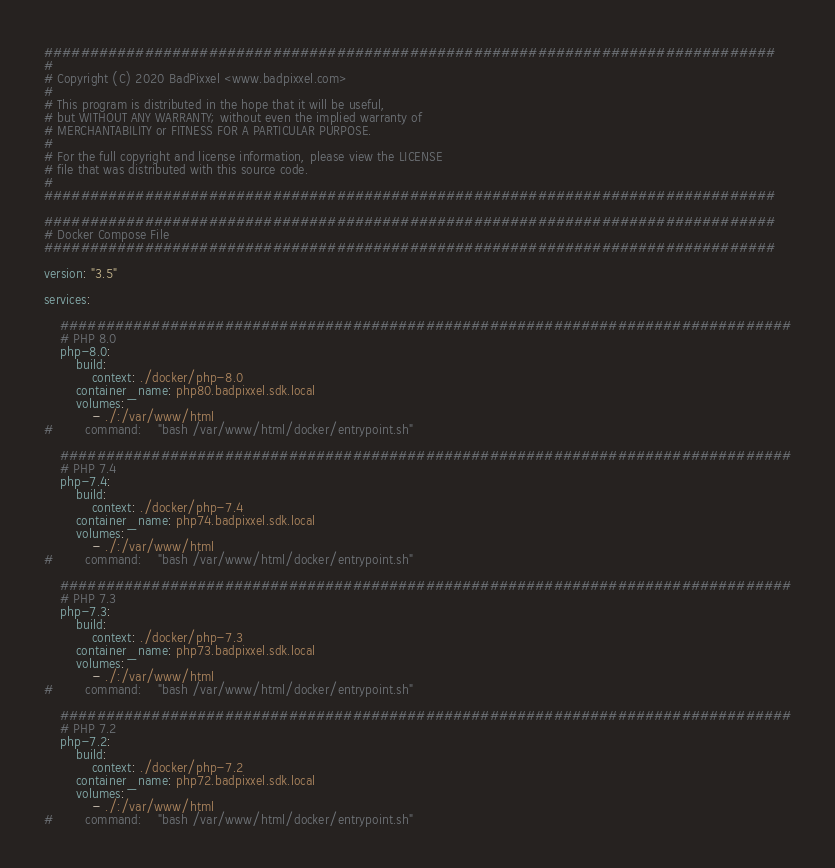Convert code to text. <code><loc_0><loc_0><loc_500><loc_500><_YAML_>
################################################################################
#
# Copyright (C) 2020 BadPixxel <www.badpixxel.com>
#
# This program is distributed in the hope that it will be useful,
# but WITHOUT ANY WARRANTY; without even the implied warranty of
# MERCHANTABILITY or FITNESS FOR A PARTICULAR PURPOSE.
#
# For the full copyright and license information, please view the LICENSE
# file that was distributed with this source code.
#
################################################################################

################################################################################
# Docker Compose File
################################################################################

version: "3.5"

services:

    ################################################################################
    # PHP 8.0
    php-8.0:
        build:
            context: ./docker/php-8.0
        container_name: php80.badpixxel.sdk.local
        volumes:
            - ./:/var/www/html
#        command:    "bash /var/www/html/docker/entrypoint.sh"

    ################################################################################
    # PHP 7.4
    php-7.4:
        build:
            context: ./docker/php-7.4
        container_name: php74.badpixxel.sdk.local
        volumes:
            - ./:/var/www/html
#        command:    "bash /var/www/html/docker/entrypoint.sh"

    ################################################################################
    # PHP 7.3
    php-7.3:
        build:
            context: ./docker/php-7.3
        container_name: php73.badpixxel.sdk.local
        volumes:
            - ./:/var/www/html
#        command:    "bash /var/www/html/docker/entrypoint.sh"

    ################################################################################
    # PHP 7.2
    php-7.2:
        build:
            context: ./docker/php-7.2
        container_name: php72.badpixxel.sdk.local
        volumes:
            - ./:/var/www/html
#        command:    "bash /var/www/html/docker/entrypoint.sh"
</code> 